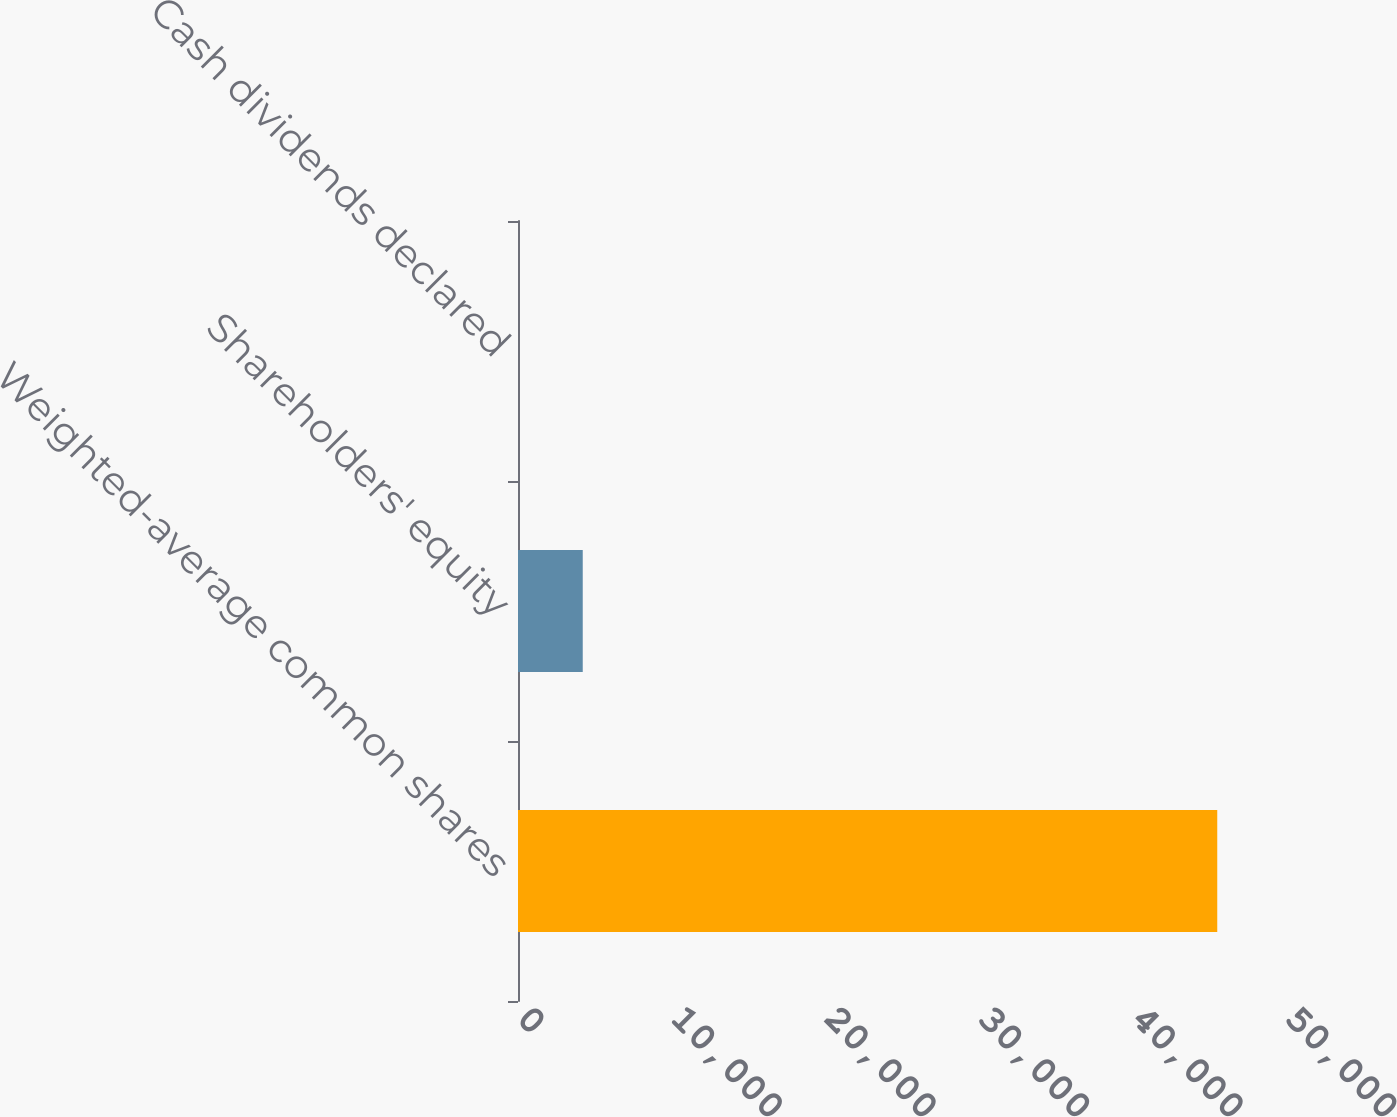Convert chart. <chart><loc_0><loc_0><loc_500><loc_500><bar_chart><fcel>Weighted-average common shares<fcel>Shareholders' equity<fcel>Cash dividends declared<nl><fcel>45524.6<fcel>4214.74<fcel>0.16<nl></chart> 